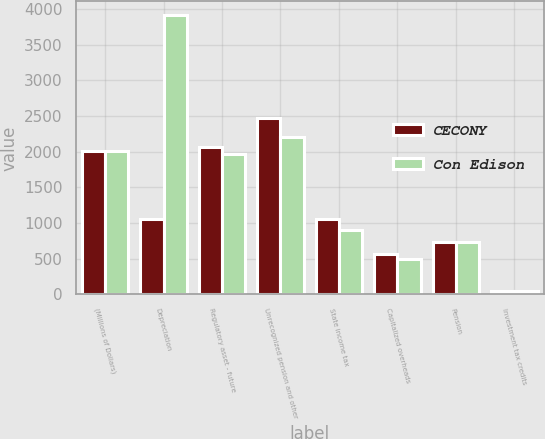Convert chart. <chart><loc_0><loc_0><loc_500><loc_500><stacked_bar_chart><ecel><fcel>(Millions of Dollars)<fcel>Depreciation<fcel>Regulatory asset - future<fcel>Unrecognized pension and other<fcel>State income tax<fcel>Capitalized overheads<fcel>Pension<fcel>Investment tax credits<nl><fcel>CECONY<fcel>2012<fcel>1060<fcel>2061<fcel>2472<fcel>1060<fcel>565<fcel>736<fcel>49<nl><fcel>Con Edison<fcel>2012<fcel>3909<fcel>1962<fcel>2202<fcel>897<fcel>496<fcel>730<fcel>47<nl></chart> 